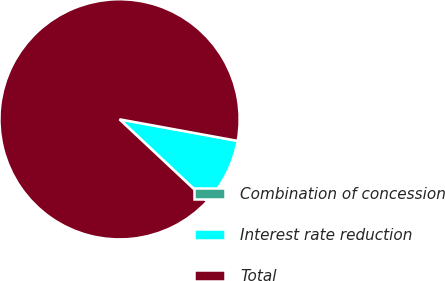<chart> <loc_0><loc_0><loc_500><loc_500><pie_chart><fcel>Combination of concession<fcel>Interest rate reduction<fcel>Total<nl><fcel>0.01%<fcel>9.1%<fcel>90.88%<nl></chart> 